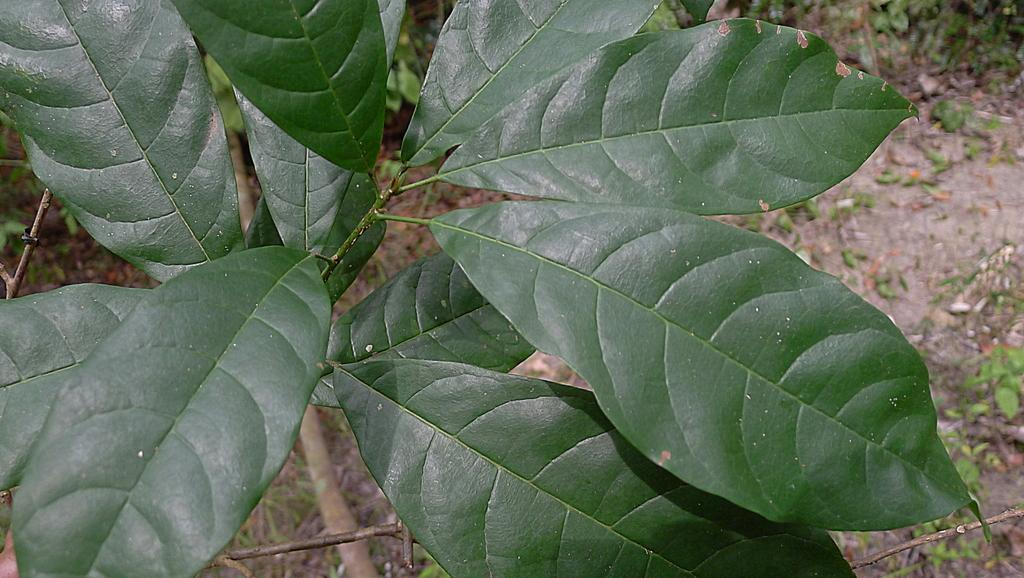What type of vegetation can be seen in the image? There are green leaves and plants in the image. Can you describe the color of the leaves in the image? The leaves in the image are green. What else is present in the image besides the plants? The provided facts do not mention any other objects or subjects in the image. What verse can be heard recited in the image? There is no mention of any verses or sounds in the image, so it cannot be determined if any verses are being recited. 